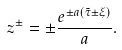Convert formula to latex. <formula><loc_0><loc_0><loc_500><loc_500>z ^ { \pm } = \pm \frac { e ^ { \pm a ( \tilde { \tau } \pm \xi ) } } { a } .</formula> 